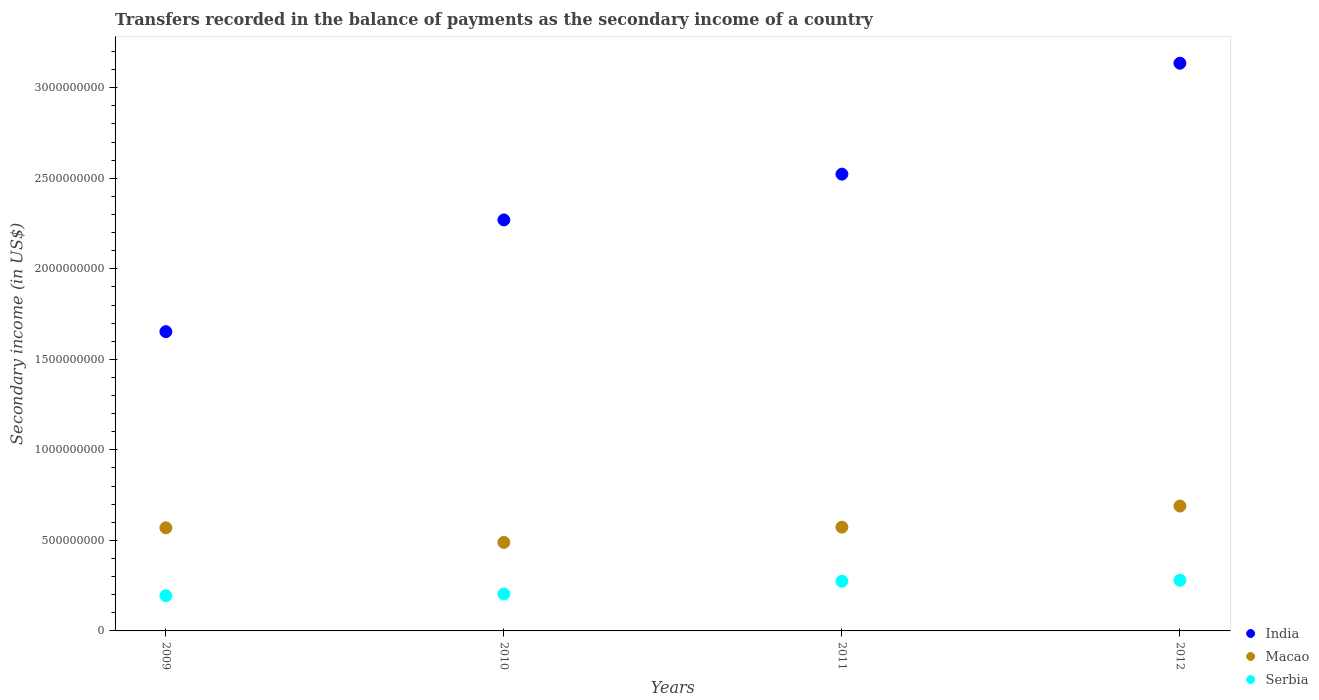Is the number of dotlines equal to the number of legend labels?
Ensure brevity in your answer.  Yes. What is the secondary income of in Macao in 2010?
Make the answer very short. 4.89e+08. Across all years, what is the maximum secondary income of in Macao?
Your answer should be very brief. 6.90e+08. Across all years, what is the minimum secondary income of in Macao?
Your answer should be compact. 4.89e+08. What is the total secondary income of in Macao in the graph?
Offer a very short reply. 2.32e+09. What is the difference between the secondary income of in India in 2011 and that in 2012?
Keep it short and to the point. -6.13e+08. What is the difference between the secondary income of in Serbia in 2011 and the secondary income of in Macao in 2010?
Your response must be concise. -2.15e+08. What is the average secondary income of in Serbia per year?
Your answer should be very brief. 2.38e+08. In the year 2010, what is the difference between the secondary income of in Macao and secondary income of in Serbia?
Give a very brief answer. 2.85e+08. What is the ratio of the secondary income of in India in 2009 to that in 2010?
Your answer should be very brief. 0.73. Is the difference between the secondary income of in Macao in 2009 and 2011 greater than the difference between the secondary income of in Serbia in 2009 and 2011?
Provide a succinct answer. Yes. What is the difference between the highest and the second highest secondary income of in Macao?
Make the answer very short. 1.17e+08. What is the difference between the highest and the lowest secondary income of in Serbia?
Give a very brief answer. 8.53e+07. Is the sum of the secondary income of in Macao in 2011 and 2012 greater than the maximum secondary income of in Serbia across all years?
Give a very brief answer. Yes. Is the secondary income of in Serbia strictly less than the secondary income of in India over the years?
Provide a short and direct response. Yes. How many dotlines are there?
Offer a terse response. 3. What is the difference between two consecutive major ticks on the Y-axis?
Offer a very short reply. 5.00e+08. What is the title of the graph?
Provide a succinct answer. Transfers recorded in the balance of payments as the secondary income of a country. What is the label or title of the Y-axis?
Keep it short and to the point. Secondary income (in US$). What is the Secondary income (in US$) in India in 2009?
Provide a succinct answer. 1.65e+09. What is the Secondary income (in US$) in Macao in 2009?
Your response must be concise. 5.69e+08. What is the Secondary income (in US$) in Serbia in 2009?
Your answer should be very brief. 1.94e+08. What is the Secondary income (in US$) in India in 2010?
Your response must be concise. 2.27e+09. What is the Secondary income (in US$) in Macao in 2010?
Make the answer very short. 4.89e+08. What is the Secondary income (in US$) in Serbia in 2010?
Your answer should be very brief. 2.04e+08. What is the Secondary income (in US$) in India in 2011?
Ensure brevity in your answer.  2.52e+09. What is the Secondary income (in US$) in Macao in 2011?
Offer a terse response. 5.73e+08. What is the Secondary income (in US$) of Serbia in 2011?
Your response must be concise. 2.74e+08. What is the Secondary income (in US$) in India in 2012?
Keep it short and to the point. 3.14e+09. What is the Secondary income (in US$) of Macao in 2012?
Provide a succinct answer. 6.90e+08. What is the Secondary income (in US$) of Serbia in 2012?
Your answer should be compact. 2.80e+08. Across all years, what is the maximum Secondary income (in US$) in India?
Provide a short and direct response. 3.14e+09. Across all years, what is the maximum Secondary income (in US$) in Macao?
Make the answer very short. 6.90e+08. Across all years, what is the maximum Secondary income (in US$) in Serbia?
Offer a terse response. 2.80e+08. Across all years, what is the minimum Secondary income (in US$) in India?
Provide a succinct answer. 1.65e+09. Across all years, what is the minimum Secondary income (in US$) in Macao?
Provide a short and direct response. 4.89e+08. Across all years, what is the minimum Secondary income (in US$) in Serbia?
Keep it short and to the point. 1.94e+08. What is the total Secondary income (in US$) in India in the graph?
Offer a very short reply. 9.58e+09. What is the total Secondary income (in US$) of Macao in the graph?
Keep it short and to the point. 2.32e+09. What is the total Secondary income (in US$) of Serbia in the graph?
Provide a short and direct response. 9.52e+08. What is the difference between the Secondary income (in US$) in India in 2009 and that in 2010?
Your answer should be very brief. -6.17e+08. What is the difference between the Secondary income (in US$) of Macao in 2009 and that in 2010?
Your response must be concise. 8.05e+07. What is the difference between the Secondary income (in US$) in Serbia in 2009 and that in 2010?
Give a very brief answer. -9.50e+06. What is the difference between the Secondary income (in US$) of India in 2009 and that in 2011?
Your response must be concise. -8.70e+08. What is the difference between the Secondary income (in US$) of Macao in 2009 and that in 2011?
Give a very brief answer. -3.74e+06. What is the difference between the Secondary income (in US$) in Serbia in 2009 and that in 2011?
Provide a short and direct response. -7.99e+07. What is the difference between the Secondary income (in US$) in India in 2009 and that in 2012?
Provide a short and direct response. -1.48e+09. What is the difference between the Secondary income (in US$) of Macao in 2009 and that in 2012?
Offer a terse response. -1.20e+08. What is the difference between the Secondary income (in US$) in Serbia in 2009 and that in 2012?
Offer a terse response. -8.53e+07. What is the difference between the Secondary income (in US$) of India in 2010 and that in 2011?
Your answer should be very brief. -2.53e+08. What is the difference between the Secondary income (in US$) of Macao in 2010 and that in 2011?
Make the answer very short. -8.42e+07. What is the difference between the Secondary income (in US$) of Serbia in 2010 and that in 2011?
Ensure brevity in your answer.  -7.04e+07. What is the difference between the Secondary income (in US$) in India in 2010 and that in 2012?
Your response must be concise. -8.66e+08. What is the difference between the Secondary income (in US$) of Macao in 2010 and that in 2012?
Offer a terse response. -2.01e+08. What is the difference between the Secondary income (in US$) of Serbia in 2010 and that in 2012?
Offer a very short reply. -7.58e+07. What is the difference between the Secondary income (in US$) of India in 2011 and that in 2012?
Provide a short and direct response. -6.13e+08. What is the difference between the Secondary income (in US$) of Macao in 2011 and that in 2012?
Provide a succinct answer. -1.17e+08. What is the difference between the Secondary income (in US$) of Serbia in 2011 and that in 2012?
Your answer should be compact. -5.39e+06. What is the difference between the Secondary income (in US$) of India in 2009 and the Secondary income (in US$) of Macao in 2010?
Offer a terse response. 1.16e+09. What is the difference between the Secondary income (in US$) of India in 2009 and the Secondary income (in US$) of Serbia in 2010?
Make the answer very short. 1.45e+09. What is the difference between the Secondary income (in US$) of Macao in 2009 and the Secondary income (in US$) of Serbia in 2010?
Offer a terse response. 3.65e+08. What is the difference between the Secondary income (in US$) in India in 2009 and the Secondary income (in US$) in Macao in 2011?
Offer a very short reply. 1.08e+09. What is the difference between the Secondary income (in US$) of India in 2009 and the Secondary income (in US$) of Serbia in 2011?
Your answer should be compact. 1.38e+09. What is the difference between the Secondary income (in US$) in Macao in 2009 and the Secondary income (in US$) in Serbia in 2011?
Provide a short and direct response. 2.95e+08. What is the difference between the Secondary income (in US$) of India in 2009 and the Secondary income (in US$) of Macao in 2012?
Ensure brevity in your answer.  9.63e+08. What is the difference between the Secondary income (in US$) of India in 2009 and the Secondary income (in US$) of Serbia in 2012?
Keep it short and to the point. 1.37e+09. What is the difference between the Secondary income (in US$) of Macao in 2009 and the Secondary income (in US$) of Serbia in 2012?
Your response must be concise. 2.90e+08. What is the difference between the Secondary income (in US$) in India in 2010 and the Secondary income (in US$) in Macao in 2011?
Provide a short and direct response. 1.70e+09. What is the difference between the Secondary income (in US$) in India in 2010 and the Secondary income (in US$) in Serbia in 2011?
Offer a terse response. 2.00e+09. What is the difference between the Secondary income (in US$) in Macao in 2010 and the Secondary income (in US$) in Serbia in 2011?
Your response must be concise. 2.15e+08. What is the difference between the Secondary income (in US$) of India in 2010 and the Secondary income (in US$) of Macao in 2012?
Offer a terse response. 1.58e+09. What is the difference between the Secondary income (in US$) of India in 2010 and the Secondary income (in US$) of Serbia in 2012?
Offer a terse response. 1.99e+09. What is the difference between the Secondary income (in US$) in Macao in 2010 and the Secondary income (in US$) in Serbia in 2012?
Your answer should be very brief. 2.09e+08. What is the difference between the Secondary income (in US$) in India in 2011 and the Secondary income (in US$) in Macao in 2012?
Keep it short and to the point. 1.83e+09. What is the difference between the Secondary income (in US$) in India in 2011 and the Secondary income (in US$) in Serbia in 2012?
Give a very brief answer. 2.24e+09. What is the difference between the Secondary income (in US$) of Macao in 2011 and the Secondary income (in US$) of Serbia in 2012?
Your answer should be compact. 2.93e+08. What is the average Secondary income (in US$) of India per year?
Provide a short and direct response. 2.40e+09. What is the average Secondary income (in US$) of Macao per year?
Your answer should be very brief. 5.80e+08. What is the average Secondary income (in US$) in Serbia per year?
Give a very brief answer. 2.38e+08. In the year 2009, what is the difference between the Secondary income (in US$) in India and Secondary income (in US$) in Macao?
Your answer should be very brief. 1.08e+09. In the year 2009, what is the difference between the Secondary income (in US$) of India and Secondary income (in US$) of Serbia?
Make the answer very short. 1.46e+09. In the year 2009, what is the difference between the Secondary income (in US$) of Macao and Secondary income (in US$) of Serbia?
Offer a terse response. 3.75e+08. In the year 2010, what is the difference between the Secondary income (in US$) of India and Secondary income (in US$) of Macao?
Provide a short and direct response. 1.78e+09. In the year 2010, what is the difference between the Secondary income (in US$) in India and Secondary income (in US$) in Serbia?
Your answer should be very brief. 2.07e+09. In the year 2010, what is the difference between the Secondary income (in US$) in Macao and Secondary income (in US$) in Serbia?
Offer a very short reply. 2.85e+08. In the year 2011, what is the difference between the Secondary income (in US$) of India and Secondary income (in US$) of Macao?
Your response must be concise. 1.95e+09. In the year 2011, what is the difference between the Secondary income (in US$) of India and Secondary income (in US$) of Serbia?
Provide a short and direct response. 2.25e+09. In the year 2011, what is the difference between the Secondary income (in US$) in Macao and Secondary income (in US$) in Serbia?
Provide a succinct answer. 2.99e+08. In the year 2012, what is the difference between the Secondary income (in US$) in India and Secondary income (in US$) in Macao?
Provide a short and direct response. 2.45e+09. In the year 2012, what is the difference between the Secondary income (in US$) in India and Secondary income (in US$) in Serbia?
Offer a very short reply. 2.86e+09. In the year 2012, what is the difference between the Secondary income (in US$) of Macao and Secondary income (in US$) of Serbia?
Keep it short and to the point. 4.10e+08. What is the ratio of the Secondary income (in US$) of India in 2009 to that in 2010?
Your answer should be very brief. 0.73. What is the ratio of the Secondary income (in US$) of Macao in 2009 to that in 2010?
Your response must be concise. 1.16. What is the ratio of the Secondary income (in US$) in Serbia in 2009 to that in 2010?
Keep it short and to the point. 0.95. What is the ratio of the Secondary income (in US$) of India in 2009 to that in 2011?
Make the answer very short. 0.66. What is the ratio of the Secondary income (in US$) in Serbia in 2009 to that in 2011?
Keep it short and to the point. 0.71. What is the ratio of the Secondary income (in US$) of India in 2009 to that in 2012?
Give a very brief answer. 0.53. What is the ratio of the Secondary income (in US$) in Macao in 2009 to that in 2012?
Make the answer very short. 0.83. What is the ratio of the Secondary income (in US$) in Serbia in 2009 to that in 2012?
Give a very brief answer. 0.7. What is the ratio of the Secondary income (in US$) in India in 2010 to that in 2011?
Keep it short and to the point. 0.9. What is the ratio of the Secondary income (in US$) of Macao in 2010 to that in 2011?
Offer a very short reply. 0.85. What is the ratio of the Secondary income (in US$) in Serbia in 2010 to that in 2011?
Provide a succinct answer. 0.74. What is the ratio of the Secondary income (in US$) of India in 2010 to that in 2012?
Your answer should be very brief. 0.72. What is the ratio of the Secondary income (in US$) of Macao in 2010 to that in 2012?
Give a very brief answer. 0.71. What is the ratio of the Secondary income (in US$) of Serbia in 2010 to that in 2012?
Make the answer very short. 0.73. What is the ratio of the Secondary income (in US$) of India in 2011 to that in 2012?
Offer a terse response. 0.8. What is the ratio of the Secondary income (in US$) in Macao in 2011 to that in 2012?
Give a very brief answer. 0.83. What is the ratio of the Secondary income (in US$) in Serbia in 2011 to that in 2012?
Your answer should be very brief. 0.98. What is the difference between the highest and the second highest Secondary income (in US$) of India?
Provide a succinct answer. 6.13e+08. What is the difference between the highest and the second highest Secondary income (in US$) of Macao?
Your answer should be compact. 1.17e+08. What is the difference between the highest and the second highest Secondary income (in US$) in Serbia?
Your answer should be compact. 5.39e+06. What is the difference between the highest and the lowest Secondary income (in US$) in India?
Provide a succinct answer. 1.48e+09. What is the difference between the highest and the lowest Secondary income (in US$) of Macao?
Your answer should be very brief. 2.01e+08. What is the difference between the highest and the lowest Secondary income (in US$) in Serbia?
Keep it short and to the point. 8.53e+07. 